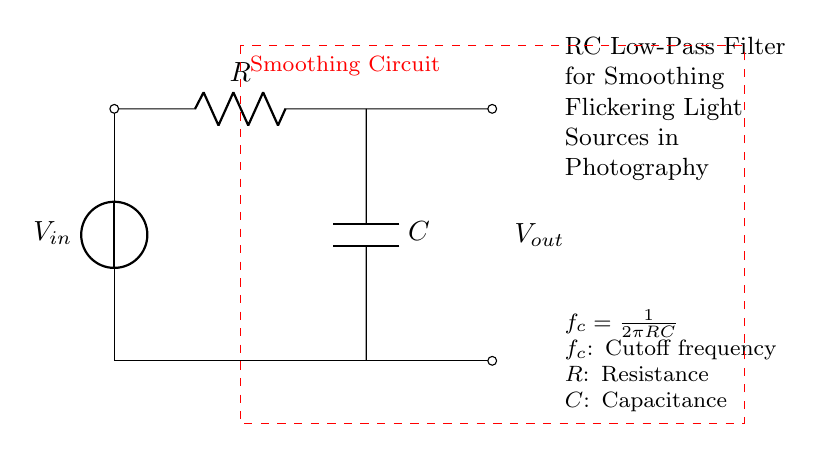What is the input voltage of the circuit? The input voltage is denoted as V_in and is the voltage source at the top of the circuit diagram.
Answer: V_in What are the two main components in this circuit? The two main components are a resistor (R) and a capacitor (C), both shown clearly in the diagram.
Answer: Resistor and Capacitor What is the purpose of this circuit? The circuit is designed as a low-pass filter to smooth out flickering light sources, as described in the accompanying notes.
Answer: Smoothing flickering light What is the formula for the cutoff frequency? The formula for the cutoff frequency f_c is given in the diagram as f_c = 1/(2πRC), which defines how the circuit behaves at different frequencies.
Answer: f_c = 1/(2πRC) How can you determine the effect of resistance on the cutoff frequency? To determine the effect of resistance on the cutoff frequency, you can analyze the formula f_c = 1/(2πRC); increasing R decreases f_c, meaning lower frequencies are allowed through.
Answer: Increase R, decrease f_c Which way does the output voltage flow? The output voltage (V_out) flows from the capacitor to the output connection, as indicated by the diagram's arrows and connections.
Answer: From the capacitor to output What happens to signals above the cutoff frequency? Signals above the cutoff frequency are attenuated, meaning they are reduced in amplitude, allowing only signals below the cutoff to pass through effectively.
Answer: Attenuated 